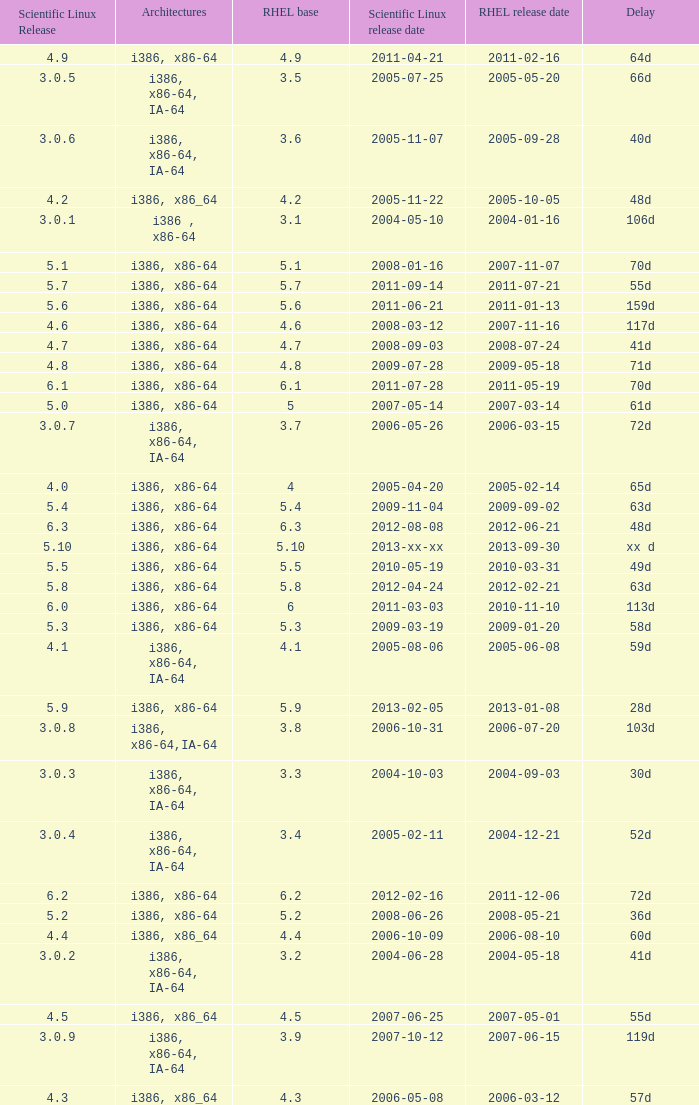What term refers to the delay in the release of scientific linux version 5.10? Xx d. 